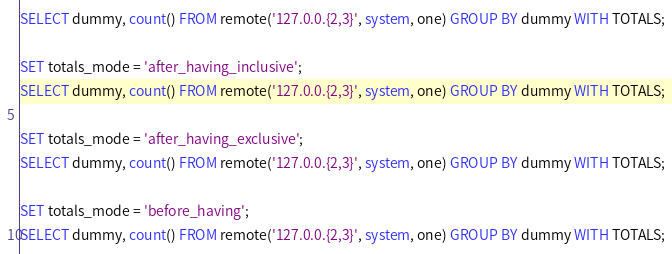Convert code to text. <code><loc_0><loc_0><loc_500><loc_500><_SQL_>SELECT dummy, count() FROM remote('127.0.0.{2,3}', system, one) GROUP BY dummy WITH TOTALS;

SET totals_mode = 'after_having_inclusive';
SELECT dummy, count() FROM remote('127.0.0.{2,3}', system, one) GROUP BY dummy WITH TOTALS;

SET totals_mode = 'after_having_exclusive';
SELECT dummy, count() FROM remote('127.0.0.{2,3}', system, one) GROUP BY dummy WITH TOTALS;

SET totals_mode = 'before_having';
SELECT dummy, count() FROM remote('127.0.0.{2,3}', system, one) GROUP BY dummy WITH TOTALS;
</code> 